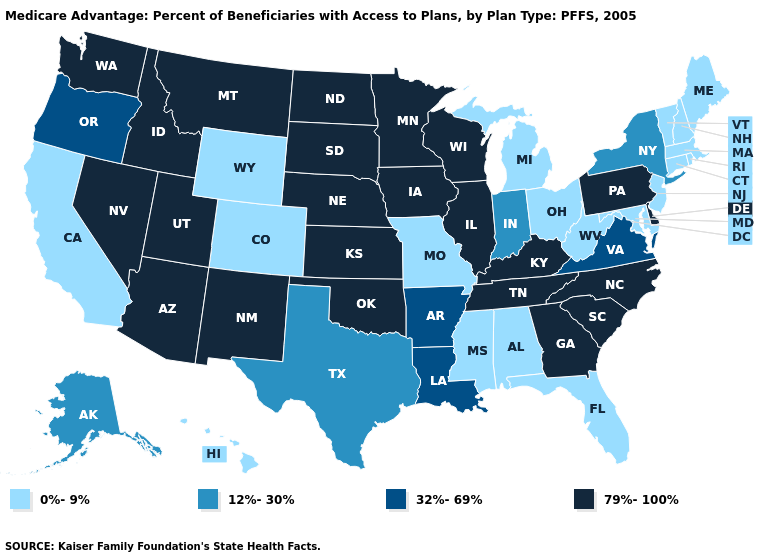What is the highest value in the USA?
Answer briefly. 79%-100%. Does the map have missing data?
Concise answer only. No. What is the value of Wisconsin?
Give a very brief answer. 79%-100%. Does the map have missing data?
Be succinct. No. What is the value of Tennessee?
Keep it brief. 79%-100%. Name the states that have a value in the range 12%-30%?
Quick response, please. Alaska, Indiana, New York, Texas. Name the states that have a value in the range 0%-9%?
Concise answer only. Alabama, California, Colorado, Connecticut, Florida, Hawaii, Massachusetts, Maryland, Maine, Michigan, Missouri, Mississippi, New Hampshire, New Jersey, Ohio, Rhode Island, Vermont, West Virginia, Wyoming. What is the highest value in states that border Tennessee?
Answer briefly. 79%-100%. Does Colorado have the lowest value in the USA?
Short answer required. Yes. Which states hav the highest value in the West?
Concise answer only. Arizona, Idaho, Montana, New Mexico, Nevada, Utah, Washington. What is the lowest value in the South?
Answer briefly. 0%-9%. Does New Hampshire have the lowest value in the USA?
Be succinct. Yes. What is the highest value in the USA?
Concise answer only. 79%-100%. What is the value of West Virginia?
Concise answer only. 0%-9%. Name the states that have a value in the range 0%-9%?
Be succinct. Alabama, California, Colorado, Connecticut, Florida, Hawaii, Massachusetts, Maryland, Maine, Michigan, Missouri, Mississippi, New Hampshire, New Jersey, Ohio, Rhode Island, Vermont, West Virginia, Wyoming. 